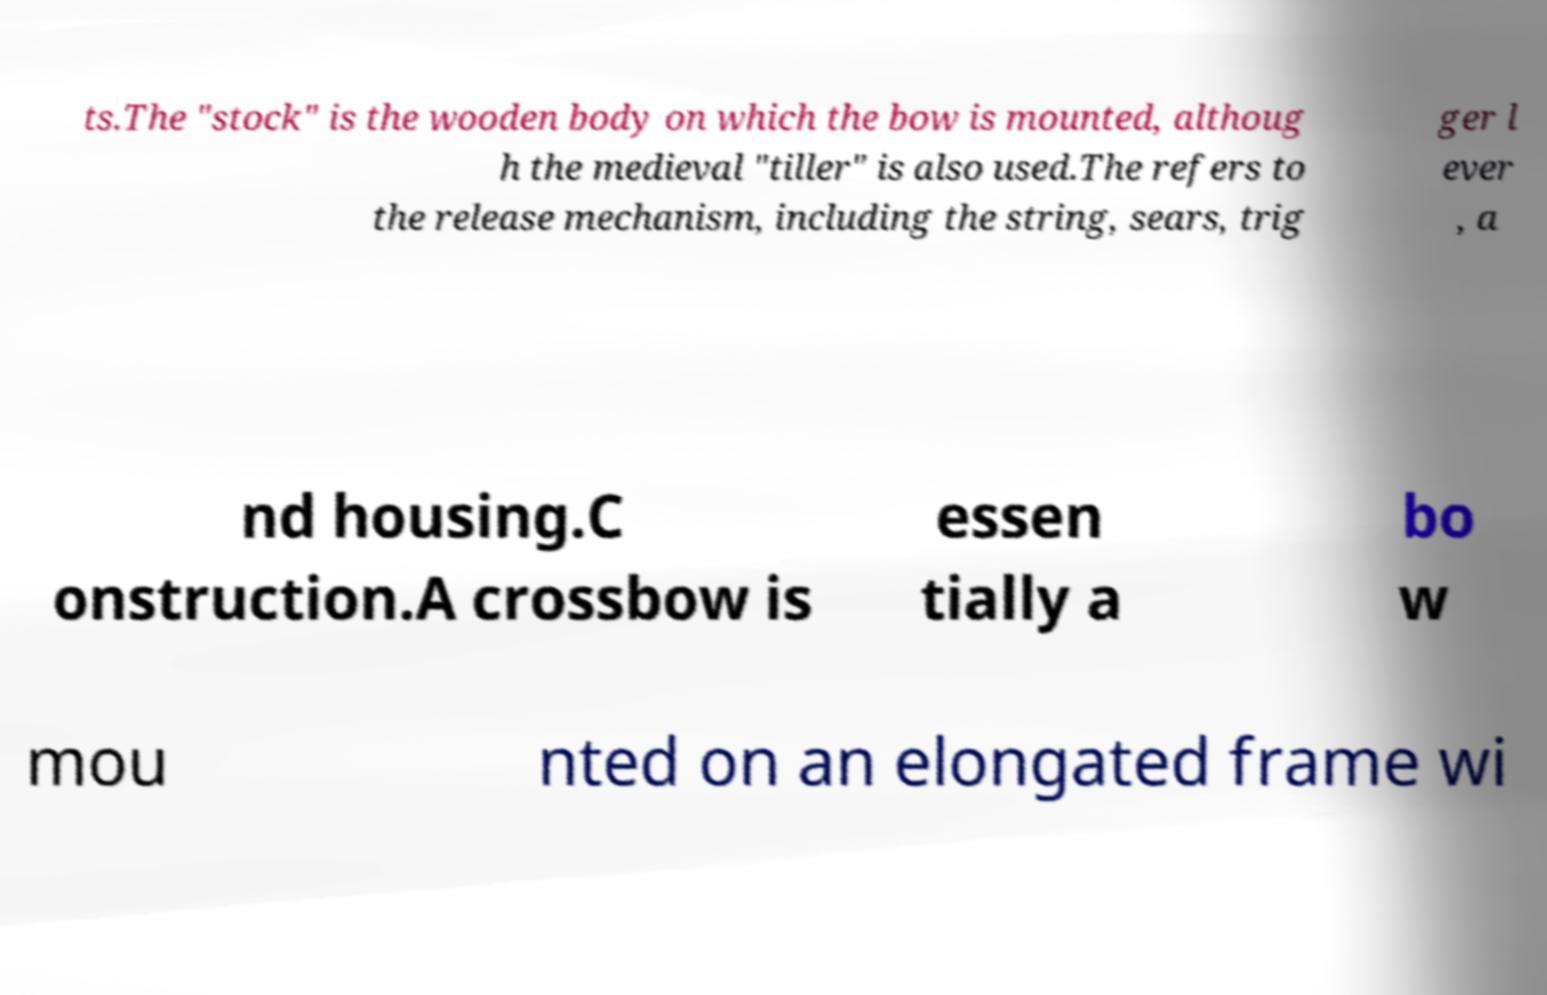Can you accurately transcribe the text from the provided image for me? ts.The "stock" is the wooden body on which the bow is mounted, althoug h the medieval "tiller" is also used.The refers to the release mechanism, including the string, sears, trig ger l ever , a nd housing.C onstruction.A crossbow is essen tially a bo w mou nted on an elongated frame wi 